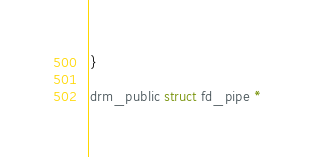<code> <loc_0><loc_0><loc_500><loc_500><_C_>}

drm_public struct fd_pipe *</code> 